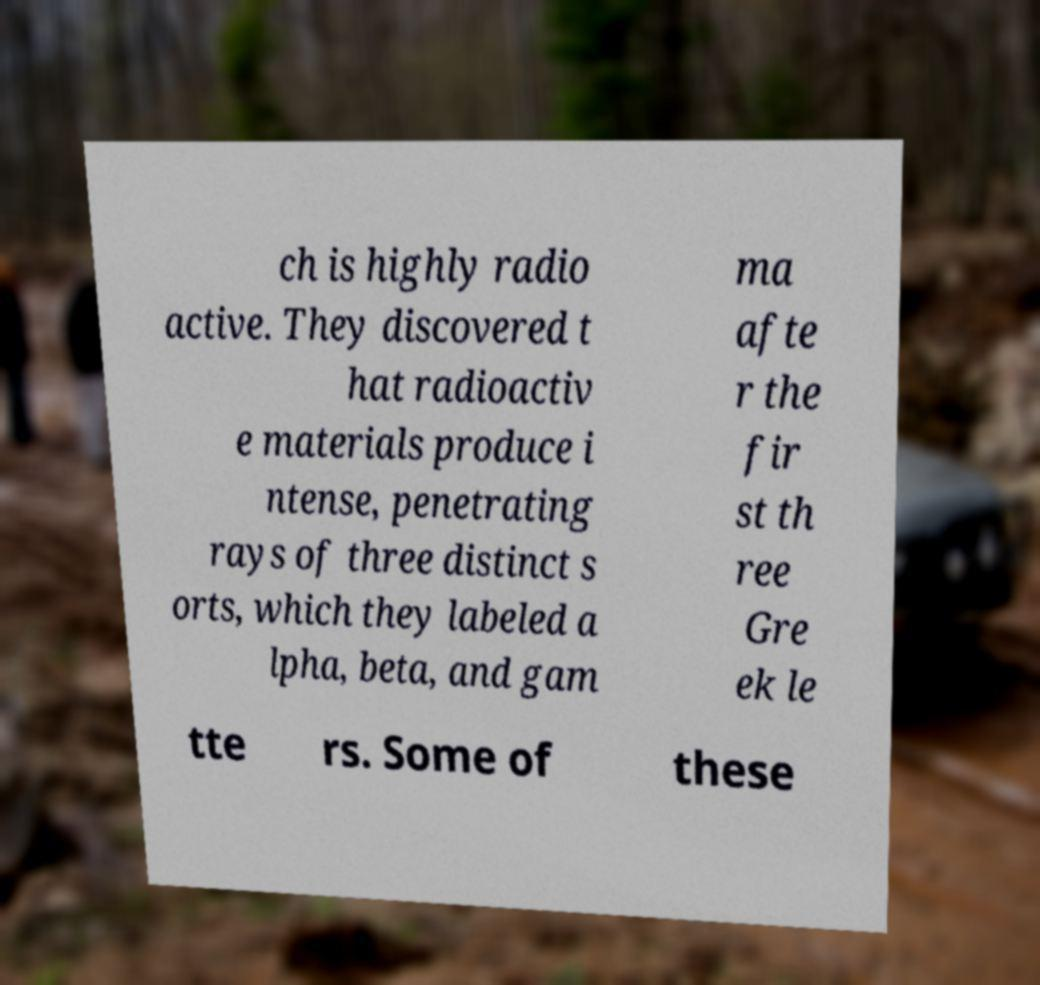What messages or text are displayed in this image? I need them in a readable, typed format. ch is highly radio active. They discovered t hat radioactiv e materials produce i ntense, penetrating rays of three distinct s orts, which they labeled a lpha, beta, and gam ma afte r the fir st th ree Gre ek le tte rs. Some of these 